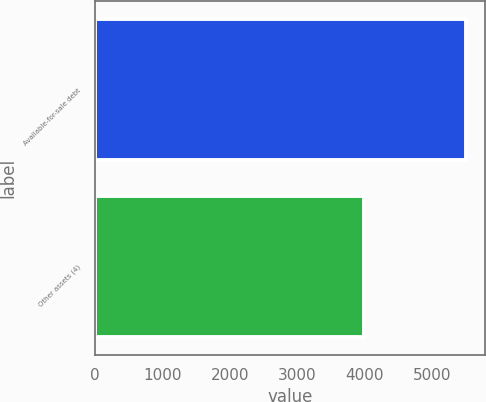Convert chart. <chart><loc_0><loc_0><loc_500><loc_500><bar_chart><fcel>Available-for-sale debt<fcel>Other assets (4)<nl><fcel>5507<fcel>3987<nl></chart> 